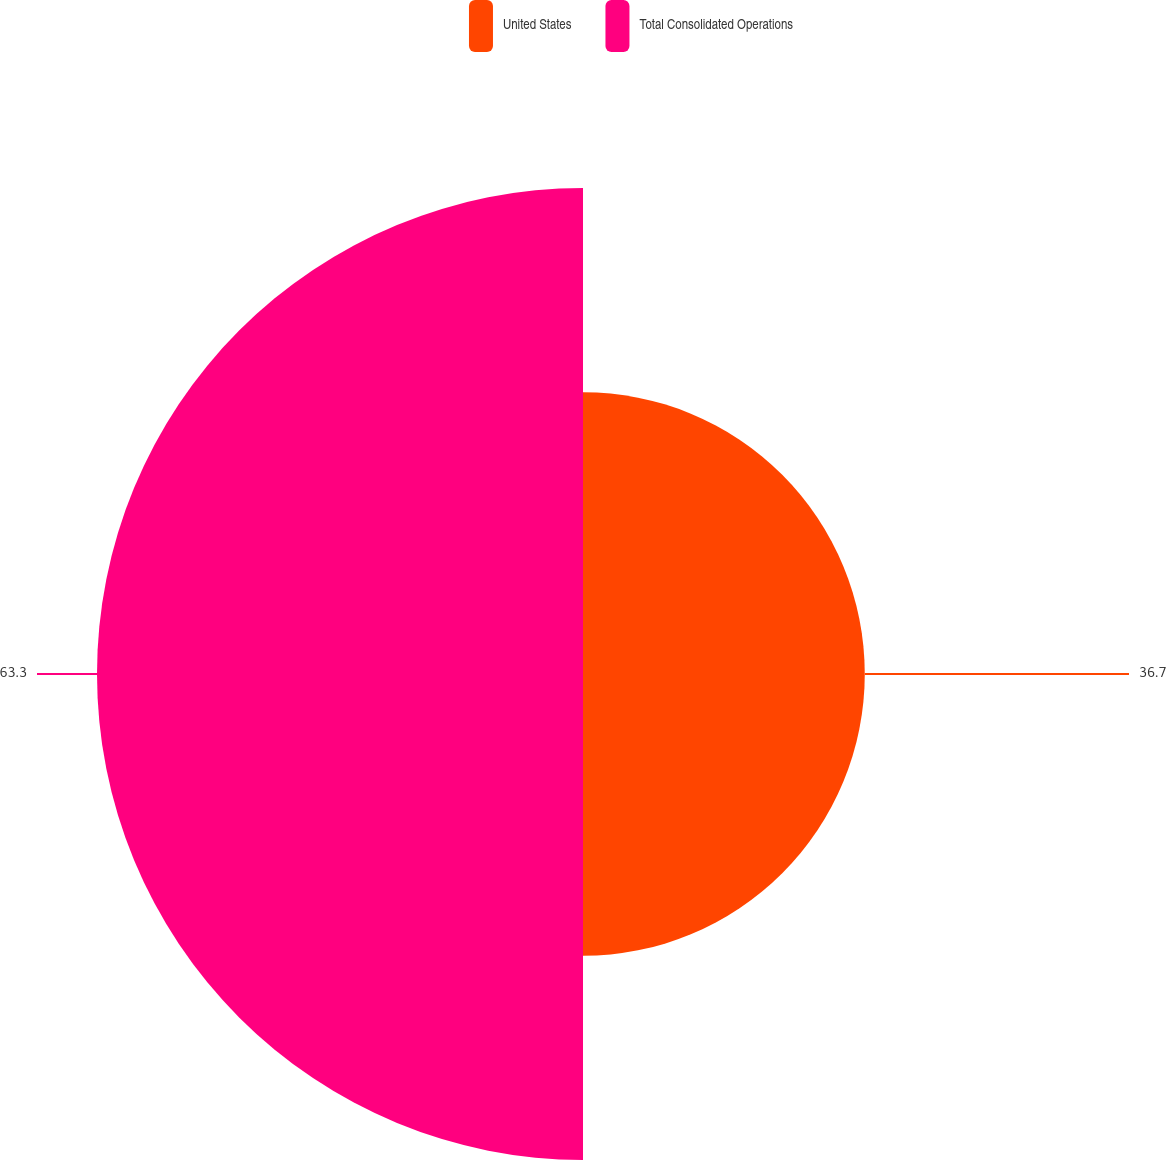<chart> <loc_0><loc_0><loc_500><loc_500><pie_chart><fcel>United States<fcel>Total Consolidated Operations<nl><fcel>36.7%<fcel>63.3%<nl></chart> 